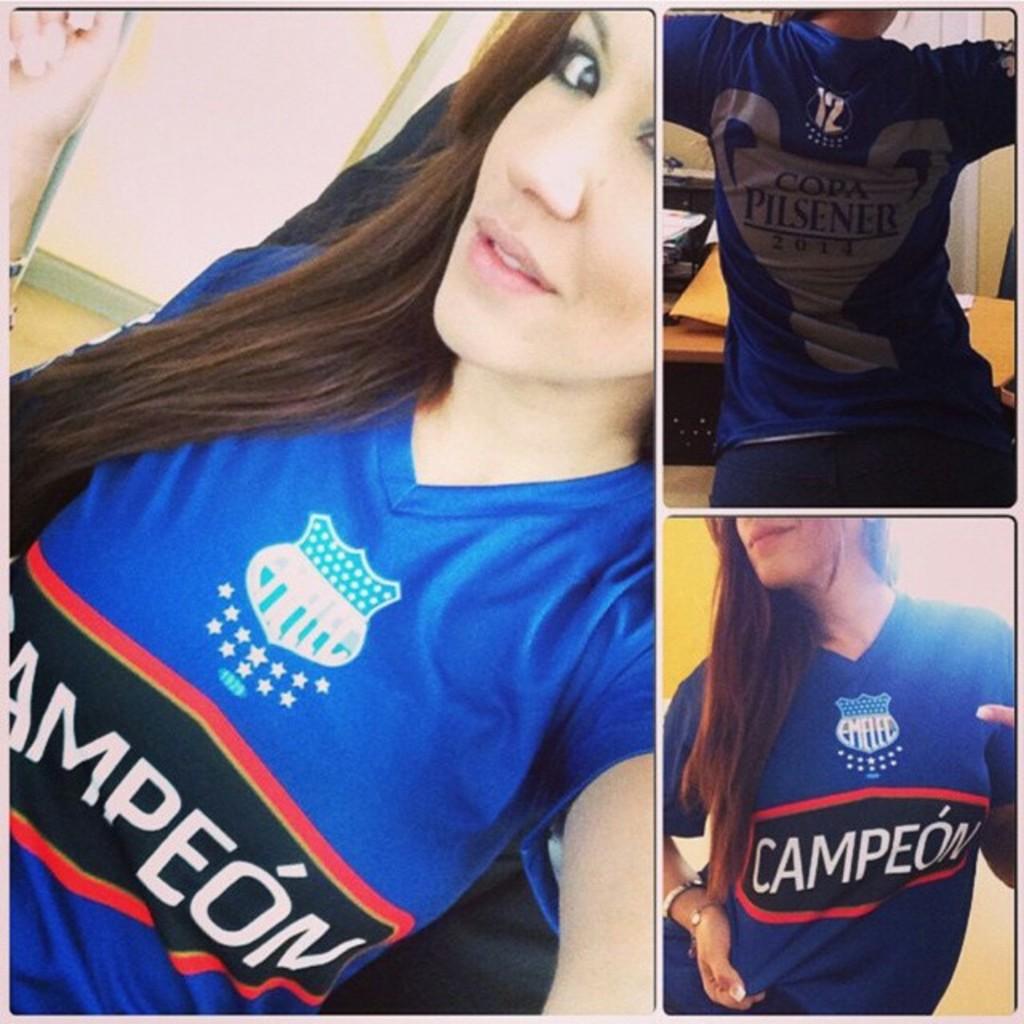What name is on the front of the shirt?
Provide a short and direct response. Campeon. 